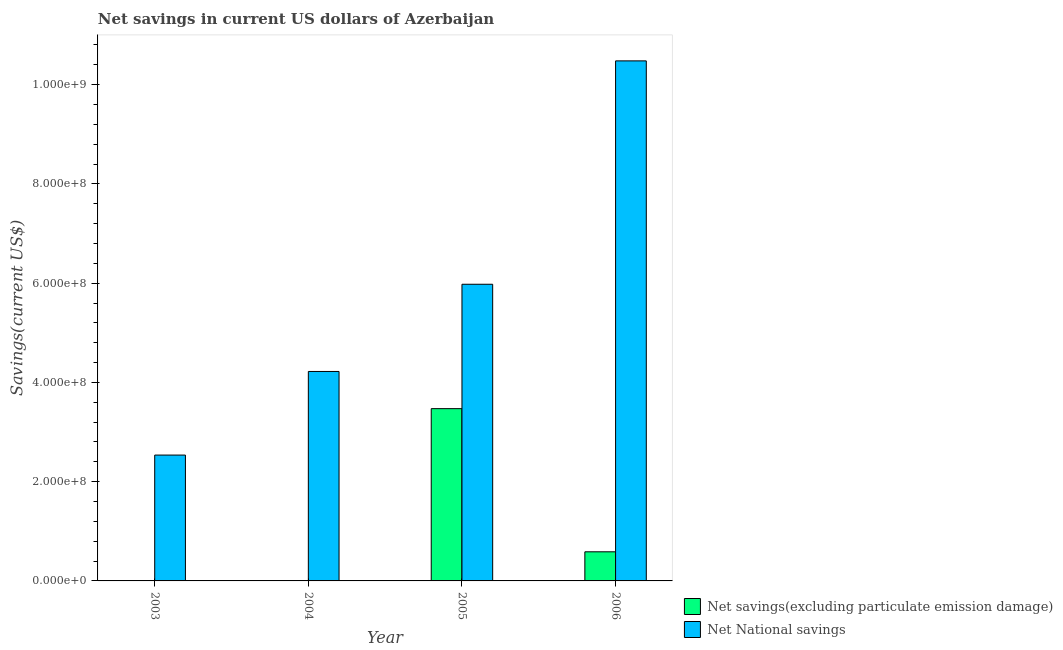Are the number of bars on each tick of the X-axis equal?
Offer a terse response. No. How many bars are there on the 2nd tick from the left?
Provide a short and direct response. 1. How many bars are there on the 4th tick from the right?
Ensure brevity in your answer.  1. In how many cases, is the number of bars for a given year not equal to the number of legend labels?
Offer a terse response. 2. What is the net national savings in 2004?
Give a very brief answer. 4.22e+08. Across all years, what is the maximum net savings(excluding particulate emission damage)?
Provide a short and direct response. 3.47e+08. Across all years, what is the minimum net savings(excluding particulate emission damage)?
Your answer should be compact. 0. What is the total net savings(excluding particulate emission damage) in the graph?
Make the answer very short. 4.06e+08. What is the difference between the net savings(excluding particulate emission damage) in 2005 and that in 2006?
Keep it short and to the point. 2.88e+08. What is the difference between the net savings(excluding particulate emission damage) in 2005 and the net national savings in 2003?
Your answer should be compact. 3.47e+08. What is the average net savings(excluding particulate emission damage) per year?
Make the answer very short. 1.01e+08. In the year 2005, what is the difference between the net savings(excluding particulate emission damage) and net national savings?
Offer a terse response. 0. In how many years, is the net national savings greater than 400000000 US$?
Keep it short and to the point. 3. What is the ratio of the net national savings in 2004 to that in 2005?
Ensure brevity in your answer.  0.71. What is the difference between the highest and the lowest net savings(excluding particulate emission damage)?
Provide a succinct answer. 3.47e+08. Is the sum of the net national savings in 2003 and 2006 greater than the maximum net savings(excluding particulate emission damage) across all years?
Keep it short and to the point. Yes. How many bars are there?
Make the answer very short. 6. How many years are there in the graph?
Your answer should be compact. 4. What is the difference between two consecutive major ticks on the Y-axis?
Provide a short and direct response. 2.00e+08. Does the graph contain any zero values?
Your answer should be very brief. Yes. How many legend labels are there?
Keep it short and to the point. 2. What is the title of the graph?
Ensure brevity in your answer.  Net savings in current US dollars of Azerbaijan. What is the label or title of the X-axis?
Offer a terse response. Year. What is the label or title of the Y-axis?
Your answer should be compact. Savings(current US$). What is the Savings(current US$) in Net savings(excluding particulate emission damage) in 2003?
Keep it short and to the point. 0. What is the Savings(current US$) in Net National savings in 2003?
Make the answer very short. 2.54e+08. What is the Savings(current US$) of Net savings(excluding particulate emission damage) in 2004?
Keep it short and to the point. 0. What is the Savings(current US$) of Net National savings in 2004?
Provide a short and direct response. 4.22e+08. What is the Savings(current US$) of Net savings(excluding particulate emission damage) in 2005?
Give a very brief answer. 3.47e+08. What is the Savings(current US$) in Net National savings in 2005?
Make the answer very short. 5.98e+08. What is the Savings(current US$) in Net savings(excluding particulate emission damage) in 2006?
Your response must be concise. 5.87e+07. What is the Savings(current US$) in Net National savings in 2006?
Offer a very short reply. 1.05e+09. Across all years, what is the maximum Savings(current US$) in Net savings(excluding particulate emission damage)?
Your answer should be compact. 3.47e+08. Across all years, what is the maximum Savings(current US$) in Net National savings?
Your answer should be compact. 1.05e+09. Across all years, what is the minimum Savings(current US$) in Net National savings?
Offer a very short reply. 2.54e+08. What is the total Savings(current US$) of Net savings(excluding particulate emission damage) in the graph?
Offer a very short reply. 4.06e+08. What is the total Savings(current US$) of Net National savings in the graph?
Keep it short and to the point. 2.32e+09. What is the difference between the Savings(current US$) in Net National savings in 2003 and that in 2004?
Give a very brief answer. -1.68e+08. What is the difference between the Savings(current US$) in Net National savings in 2003 and that in 2005?
Keep it short and to the point. -3.44e+08. What is the difference between the Savings(current US$) in Net National savings in 2003 and that in 2006?
Provide a short and direct response. -7.94e+08. What is the difference between the Savings(current US$) in Net National savings in 2004 and that in 2005?
Your answer should be very brief. -1.76e+08. What is the difference between the Savings(current US$) in Net National savings in 2004 and that in 2006?
Provide a short and direct response. -6.26e+08. What is the difference between the Savings(current US$) of Net savings(excluding particulate emission damage) in 2005 and that in 2006?
Offer a terse response. 2.88e+08. What is the difference between the Savings(current US$) in Net National savings in 2005 and that in 2006?
Ensure brevity in your answer.  -4.50e+08. What is the difference between the Savings(current US$) of Net savings(excluding particulate emission damage) in 2005 and the Savings(current US$) of Net National savings in 2006?
Make the answer very short. -7.01e+08. What is the average Savings(current US$) of Net savings(excluding particulate emission damage) per year?
Give a very brief answer. 1.01e+08. What is the average Savings(current US$) of Net National savings per year?
Give a very brief answer. 5.80e+08. In the year 2005, what is the difference between the Savings(current US$) of Net savings(excluding particulate emission damage) and Savings(current US$) of Net National savings?
Offer a terse response. -2.51e+08. In the year 2006, what is the difference between the Savings(current US$) in Net savings(excluding particulate emission damage) and Savings(current US$) in Net National savings?
Offer a very short reply. -9.89e+08. What is the ratio of the Savings(current US$) in Net National savings in 2003 to that in 2004?
Provide a short and direct response. 0.6. What is the ratio of the Savings(current US$) in Net National savings in 2003 to that in 2005?
Your answer should be very brief. 0.42. What is the ratio of the Savings(current US$) in Net National savings in 2003 to that in 2006?
Your response must be concise. 0.24. What is the ratio of the Savings(current US$) in Net National savings in 2004 to that in 2005?
Your response must be concise. 0.71. What is the ratio of the Savings(current US$) of Net National savings in 2004 to that in 2006?
Make the answer very short. 0.4. What is the ratio of the Savings(current US$) in Net savings(excluding particulate emission damage) in 2005 to that in 2006?
Provide a short and direct response. 5.92. What is the ratio of the Savings(current US$) of Net National savings in 2005 to that in 2006?
Ensure brevity in your answer.  0.57. What is the difference between the highest and the second highest Savings(current US$) in Net National savings?
Give a very brief answer. 4.50e+08. What is the difference between the highest and the lowest Savings(current US$) in Net savings(excluding particulate emission damage)?
Your response must be concise. 3.47e+08. What is the difference between the highest and the lowest Savings(current US$) in Net National savings?
Give a very brief answer. 7.94e+08. 